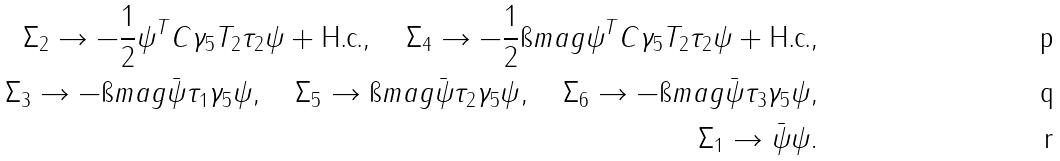<formula> <loc_0><loc_0><loc_500><loc_500>\Sigma _ { 2 } \to - \frac { 1 } { 2 } \psi ^ { T } C \gamma _ { 5 } T _ { 2 } \tau _ { 2 } \psi + \text {H.c.} , \quad \Sigma _ { 4 } \to - \frac { 1 } { 2 } \i m a g \psi ^ { T } C \gamma _ { 5 } T _ { 2 } \tau _ { 2 } \psi + \text {H.c.} , \\ \Sigma _ { 3 } \to - \i m a g \bar { \psi } \tau _ { 1 } \gamma _ { 5 } \psi , \quad \Sigma _ { 5 } \to \i m a g \bar { \psi } \tau _ { 2 } \gamma _ { 5 } \psi , \quad \Sigma _ { 6 } \to - \i m a g \bar { \psi } \tau _ { 3 } \gamma _ { 5 } \psi , \\ \Sigma _ { 1 } \to \bar { \psi } \psi .</formula> 